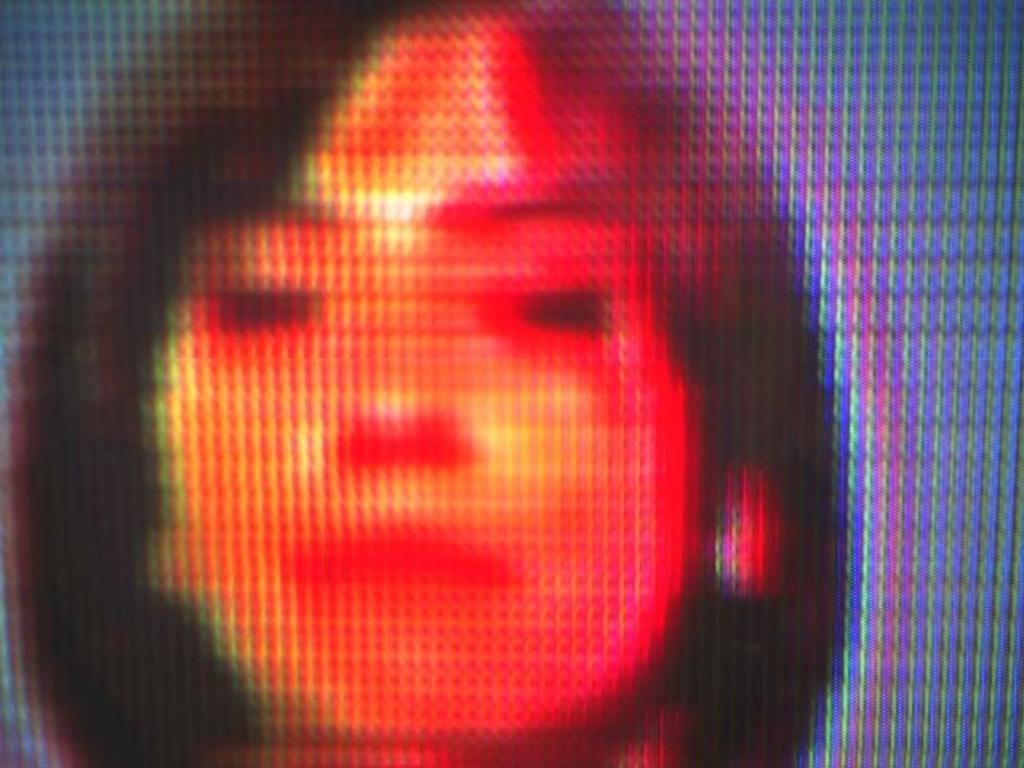What type of image is being described? The image is an edited picture. Can you describe the main subject of the image? There is a woman in the image. What type of army equipment can be seen in the image? There is no army equipment present in the image; it only features a woman. What type of bag is the woman carrying in the image? The image does not show the woman carrying a bag. 